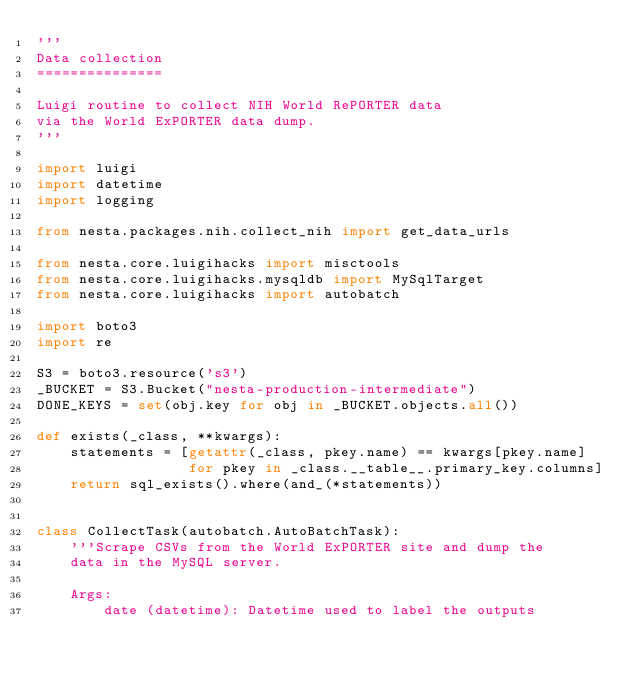<code> <loc_0><loc_0><loc_500><loc_500><_Python_>'''
Data collection
===============

Luigi routine to collect NIH World RePORTER data
via the World ExPORTER data dump.
'''

import luigi
import datetime
import logging

from nesta.packages.nih.collect_nih import get_data_urls

from nesta.core.luigihacks import misctools
from nesta.core.luigihacks.mysqldb import MySqlTarget
from nesta.core.luigihacks import autobatch

import boto3
import re

S3 = boto3.resource('s3')
_BUCKET = S3.Bucket("nesta-production-intermediate")
DONE_KEYS = set(obj.key for obj in _BUCKET.objects.all())

def exists(_class, **kwargs):
    statements = [getattr(_class, pkey.name) == kwargs[pkey.name]
                  for pkey in _class.__table__.primary_key.columns]
    return sql_exists().where(and_(*statements))


class CollectTask(autobatch.AutoBatchTask):
    '''Scrape CSVs from the World ExPORTER site and dump the
    data in the MySQL server.

    Args:
        date (datetime): Datetime used to label the outputs</code> 